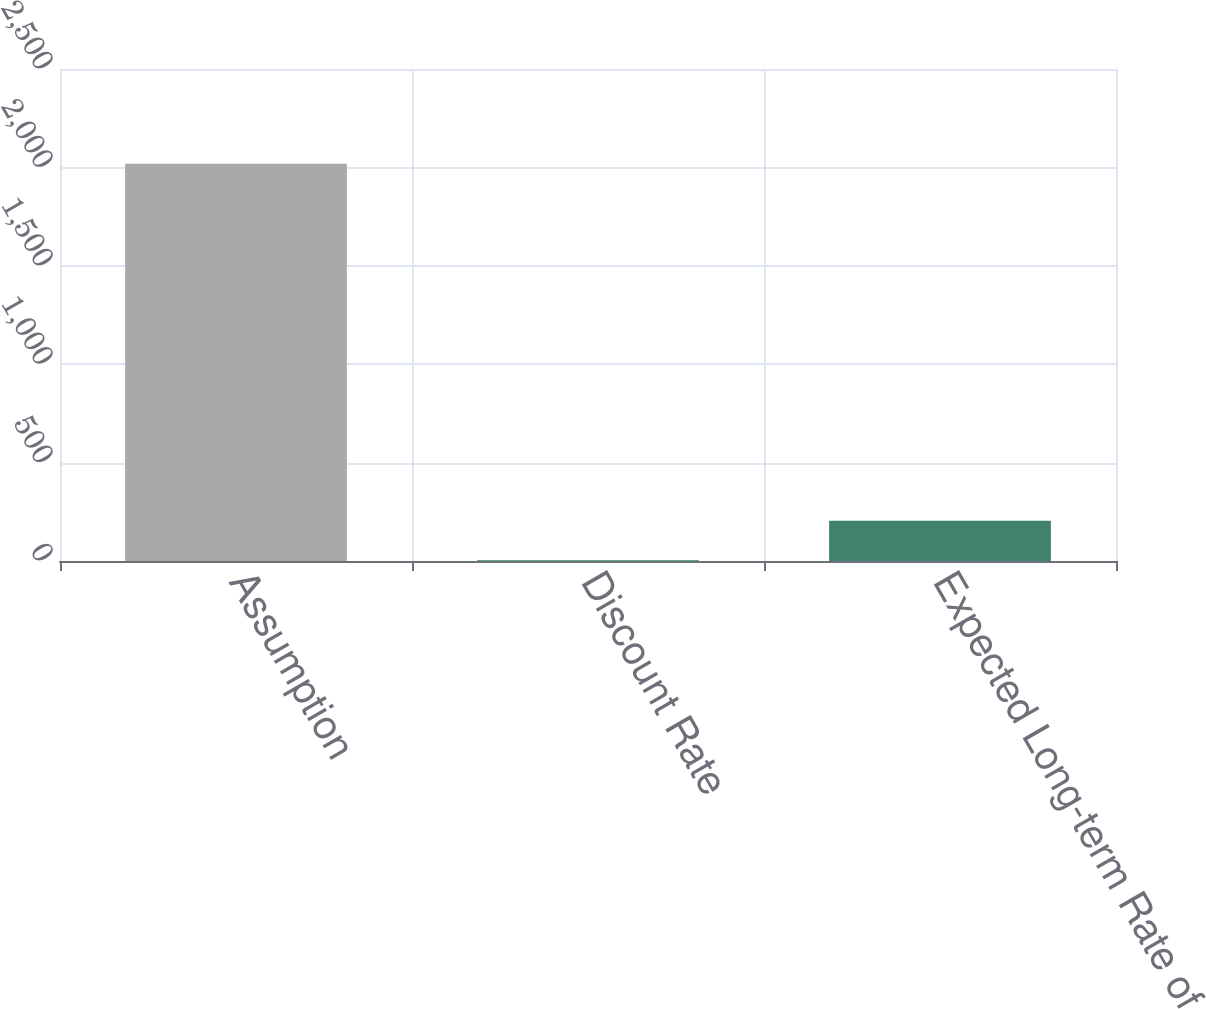Convert chart. <chart><loc_0><loc_0><loc_500><loc_500><bar_chart><fcel>Assumption<fcel>Discount Rate<fcel>Expected Long-term Rate of<nl><fcel>2018<fcel>3.7<fcel>205.13<nl></chart> 